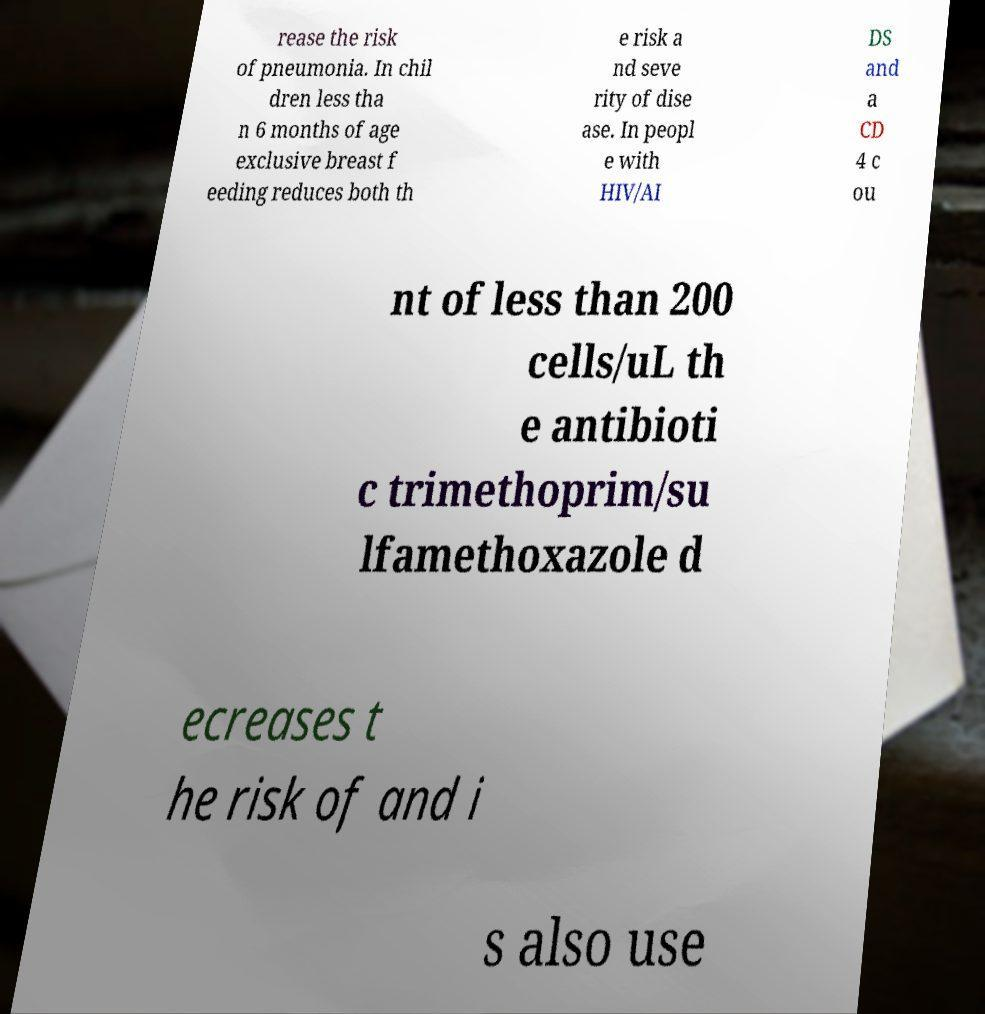Can you accurately transcribe the text from the provided image for me? rease the risk of pneumonia. In chil dren less tha n 6 months of age exclusive breast f eeding reduces both th e risk a nd seve rity of dise ase. In peopl e with HIV/AI DS and a CD 4 c ou nt of less than 200 cells/uL th e antibioti c trimethoprim/su lfamethoxazole d ecreases t he risk of and i s also use 